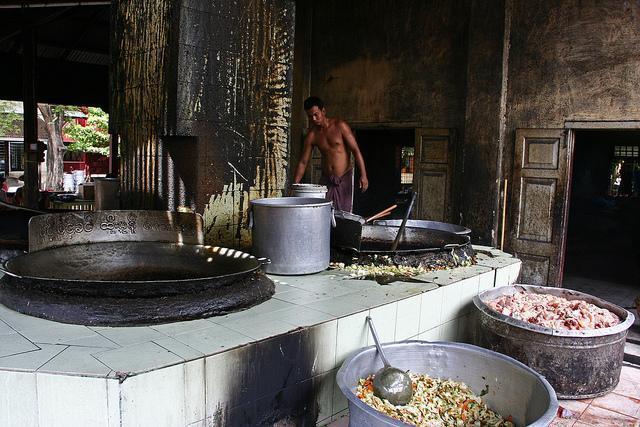How many bowls are visible?
Give a very brief answer. 2. 